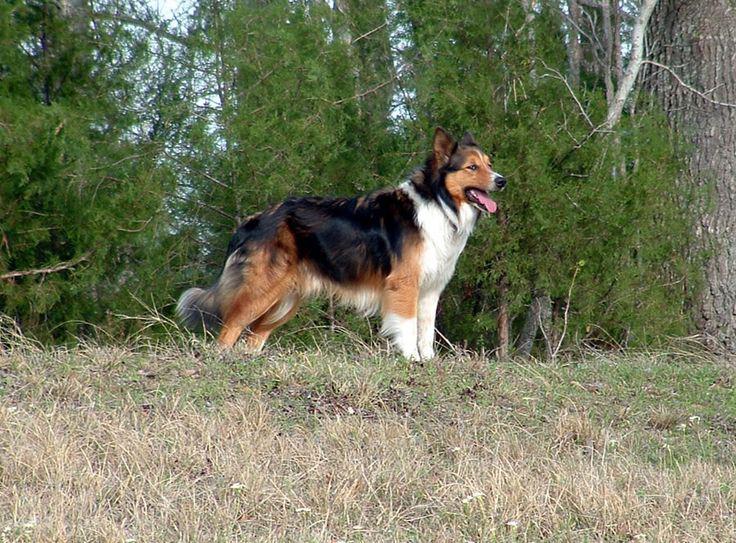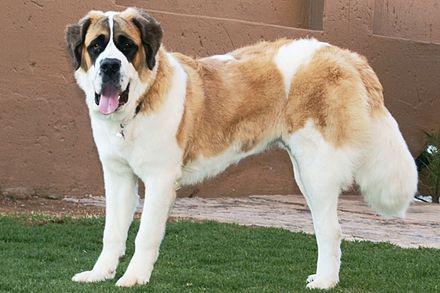The first image is the image on the left, the second image is the image on the right. Analyze the images presented: Is the assertion "One of the dogs is resting on the ground." valid? Answer yes or no. No. 